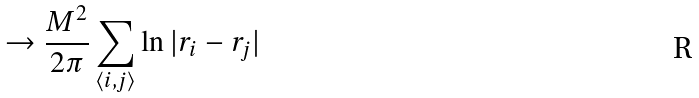<formula> <loc_0><loc_0><loc_500><loc_500>\to \frac { M ^ { 2 } } { 2 \pi } \sum _ { \langle i , j \rangle } \ln | { r } _ { i } - { r } _ { j } |</formula> 